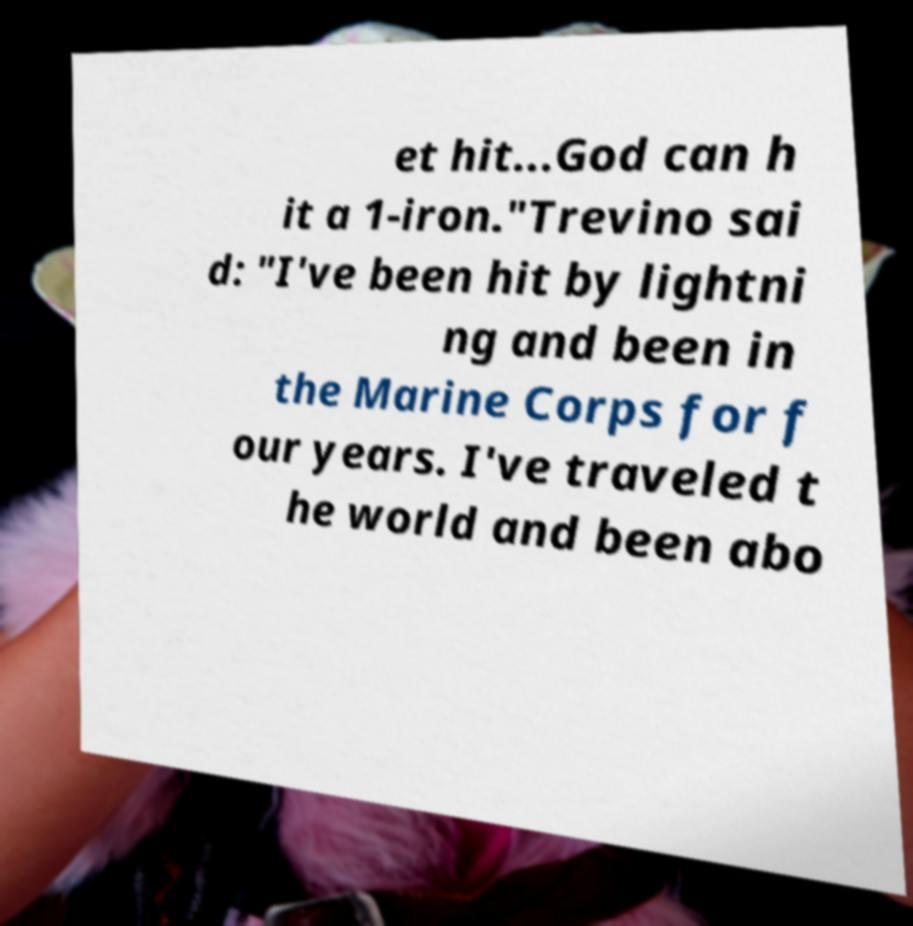For documentation purposes, I need the text within this image transcribed. Could you provide that? et hit...God can h it a 1-iron."Trevino sai d: "I've been hit by lightni ng and been in the Marine Corps for f our years. I've traveled t he world and been abo 